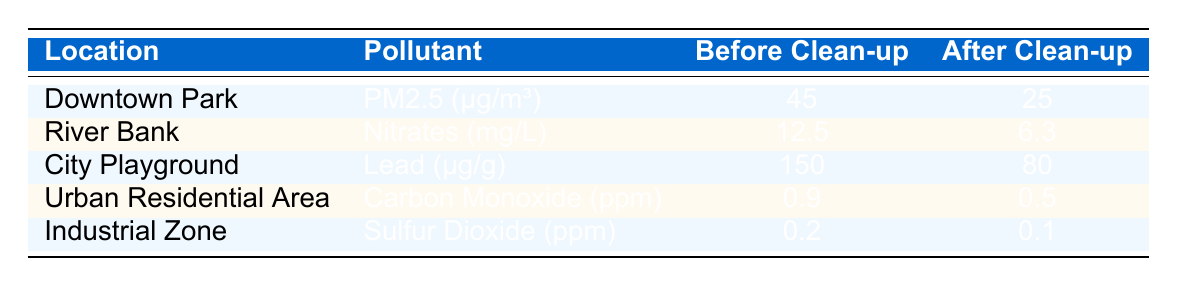What was the PM2.5 level at Downtown Park before the clean-up? The table shows the PM2.5 level at Downtown Park before the clean-up as 45 µg/m³.
Answer: 45 µg/m³ What is the level of Nitrates after the clean-up at River Bank? According to the table, after the clean-up, the level of Nitrates at River Bank is 6.3 mg/L.
Answer: 6.3 mg/L Is the lead level at City Playground higher before or after the clean-up? The table indicates a lead level of 150 µg/g before the clean-up and 80 µg/g after the clean-up, showing it is higher before.
Answer: Higher before What is the difference in Carbon Monoxide levels before and after the clean-up in Urban Residential Area? The before clean-up level of Carbon Monoxide is 0.9 ppm and after is 0.5 ppm. The difference is 0.9 - 0.5 = 0.4 ppm.
Answer: 0.4 ppm What was the average level of pollution (across all pollutants) before the clean-up? To find the average before clean-up: (45 + 12.5 + 150 + 0.9 + 0.2) = 208.6. There are 5 locations, so the average is 208.6 / 5 = 41.72.
Answer: 41.72 Was the pollution level of Sulfur Dioxide at the Industrial Zone reduced by at least 50% after the clean-up? The level before was 0.2 ppm and after was 0.1 ppm. The reduction is (0.2 - 0.1) = 0.1 ppm, which is a 50% reduction (0.1/0.2 = 0.5). Therefore, yes.
Answer: Yes Which location saw the most significant reduction in pollutant levels after the clean-up? To determine the most significant reduction, we calculate the difference for each location: Downtown Park: 20 µg/m³, River Bank: 6.2 mg/L, City Playground: 70 µg/g, Urban Residential Area: 0.4 ppm, Industrial Zone: 0.1 ppm. The City Playground saw the largest reduction of 70 µg/g.
Answer: City Playground Are there any pollutants that have levels higher after the clean-up? Checking the table, all pollutants have reduced levels after the clean-up, as no values after are higher than those before.
Answer: No What is the median pollutant level before the clean-up? Sorting the before clean-up values: 0.2, 0.9, 12.5, 45, 150. The median is the middle value, which is 12.5 (the third value).
Answer: 12.5 